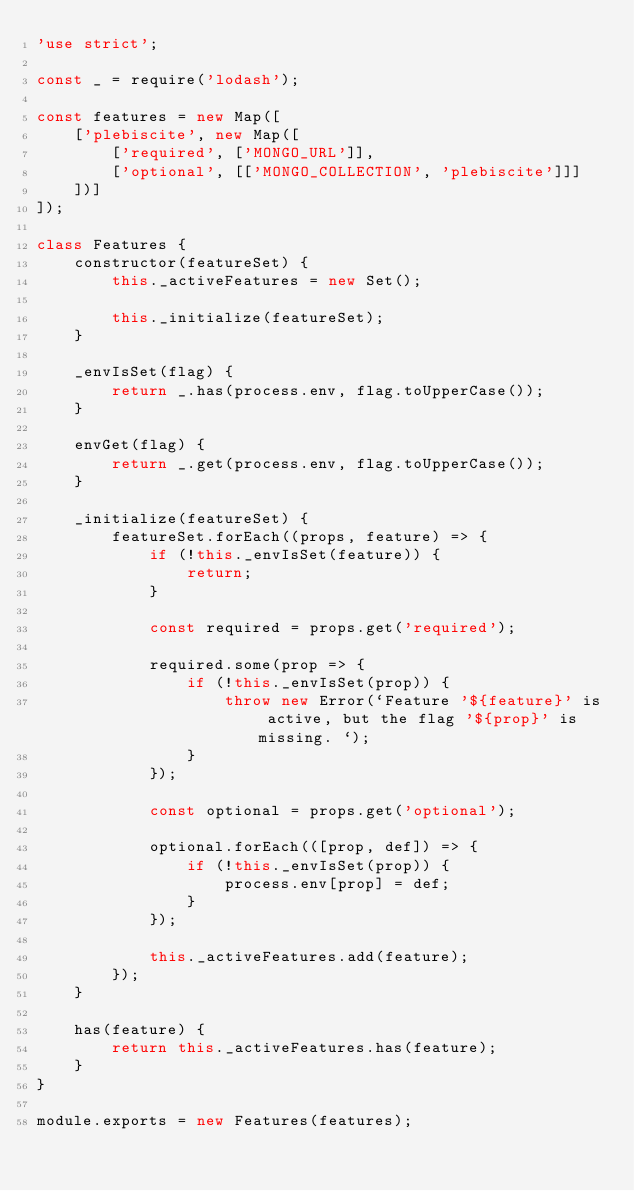<code> <loc_0><loc_0><loc_500><loc_500><_JavaScript_>'use strict';

const _ = require('lodash');

const features = new Map([
    ['plebiscite', new Map([
        ['required', ['MONGO_URL']],
        ['optional', [['MONGO_COLLECTION', 'plebiscite']]]
    ])]
]);

class Features {
    constructor(featureSet) {
        this._activeFeatures = new Set();

        this._initialize(featureSet);
    }

    _envIsSet(flag) {
        return _.has(process.env, flag.toUpperCase());
    }

    envGet(flag) {
        return _.get(process.env, flag.toUpperCase());
    }

    _initialize(featureSet) {
        featureSet.forEach((props, feature) => {
            if (!this._envIsSet(feature)) {
                return;
            }

            const required = props.get('required');

            required.some(prop => {
                if (!this._envIsSet(prop)) {
                    throw new Error(`Feature '${feature}' is active, but the flag '${prop}' is missing. `);
                }
            });

            const optional = props.get('optional');

            optional.forEach(([prop, def]) => {
                if (!this._envIsSet(prop)) {
                    process.env[prop] = def;
                }
            });

            this._activeFeatures.add(feature);
        });
    }

    has(feature) {
        return this._activeFeatures.has(feature);
    }
}

module.exports = new Features(features);</code> 